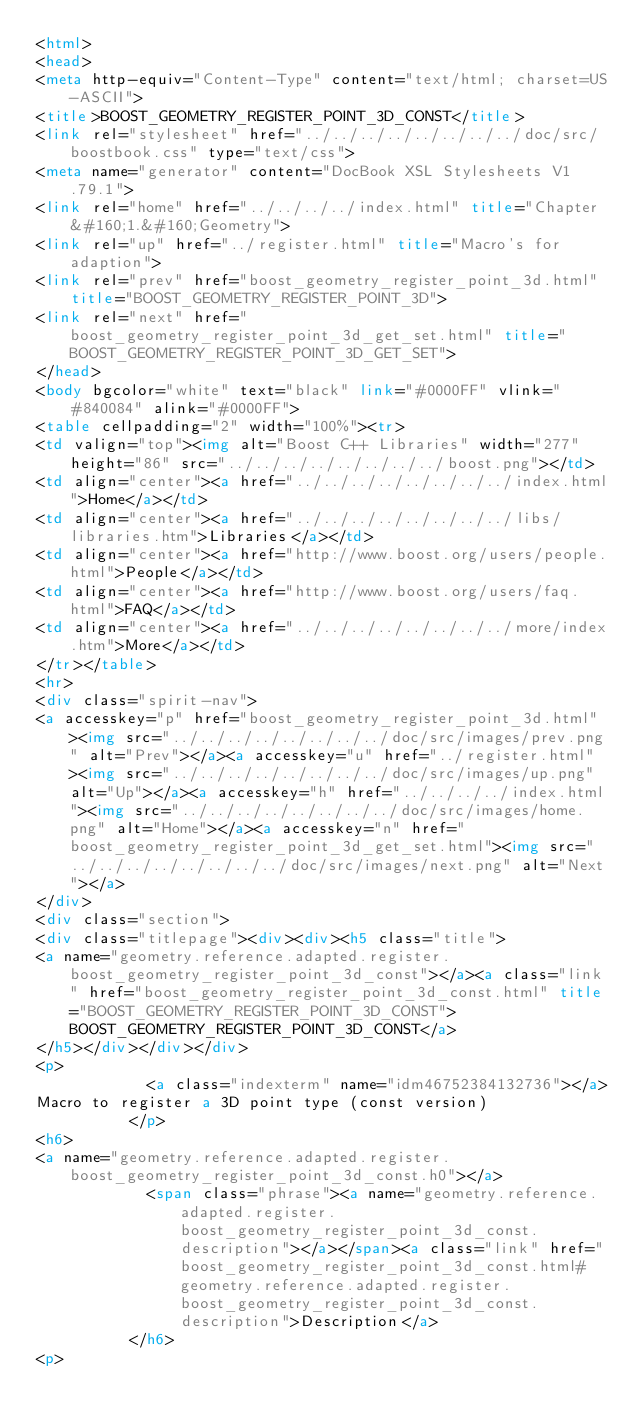<code> <loc_0><loc_0><loc_500><loc_500><_HTML_><html>
<head>
<meta http-equiv="Content-Type" content="text/html; charset=US-ASCII">
<title>BOOST_GEOMETRY_REGISTER_POINT_3D_CONST</title>
<link rel="stylesheet" href="../../../../../../../../doc/src/boostbook.css" type="text/css">
<meta name="generator" content="DocBook XSL Stylesheets V1.79.1">
<link rel="home" href="../../../../index.html" title="Chapter&#160;1.&#160;Geometry">
<link rel="up" href="../register.html" title="Macro's for adaption">
<link rel="prev" href="boost_geometry_register_point_3d.html" title="BOOST_GEOMETRY_REGISTER_POINT_3D">
<link rel="next" href="boost_geometry_register_point_3d_get_set.html" title="BOOST_GEOMETRY_REGISTER_POINT_3D_GET_SET">
</head>
<body bgcolor="white" text="black" link="#0000FF" vlink="#840084" alink="#0000FF">
<table cellpadding="2" width="100%"><tr>
<td valign="top"><img alt="Boost C++ Libraries" width="277" height="86" src="../../../../../../../../boost.png"></td>
<td align="center"><a href="../../../../../../../../index.html">Home</a></td>
<td align="center"><a href="../../../../../../../../libs/libraries.htm">Libraries</a></td>
<td align="center"><a href="http://www.boost.org/users/people.html">People</a></td>
<td align="center"><a href="http://www.boost.org/users/faq.html">FAQ</a></td>
<td align="center"><a href="../../../../../../../../more/index.htm">More</a></td>
</tr></table>
<hr>
<div class="spirit-nav">
<a accesskey="p" href="boost_geometry_register_point_3d.html"><img src="../../../../../../../../doc/src/images/prev.png" alt="Prev"></a><a accesskey="u" href="../register.html"><img src="../../../../../../../../doc/src/images/up.png" alt="Up"></a><a accesskey="h" href="../../../../index.html"><img src="../../../../../../../../doc/src/images/home.png" alt="Home"></a><a accesskey="n" href="boost_geometry_register_point_3d_get_set.html"><img src="../../../../../../../../doc/src/images/next.png" alt="Next"></a>
</div>
<div class="section">
<div class="titlepage"><div><div><h5 class="title">
<a name="geometry.reference.adapted.register.boost_geometry_register_point_3d_const"></a><a class="link" href="boost_geometry_register_point_3d_const.html" title="BOOST_GEOMETRY_REGISTER_POINT_3D_CONST">BOOST_GEOMETRY_REGISTER_POINT_3D_CONST</a>
</h5></div></div></div>
<p>
            <a class="indexterm" name="idm46752384132736"></a>
Macro to register a 3D point type (const version)
          </p>
<h6>
<a name="geometry.reference.adapted.register.boost_geometry_register_point_3d_const.h0"></a>
            <span class="phrase"><a name="geometry.reference.adapted.register.boost_geometry_register_point_3d_const.description"></a></span><a class="link" href="boost_geometry_register_point_3d_const.html#geometry.reference.adapted.register.boost_geometry_register_point_3d_const.description">Description</a>
          </h6>
<p></code> 